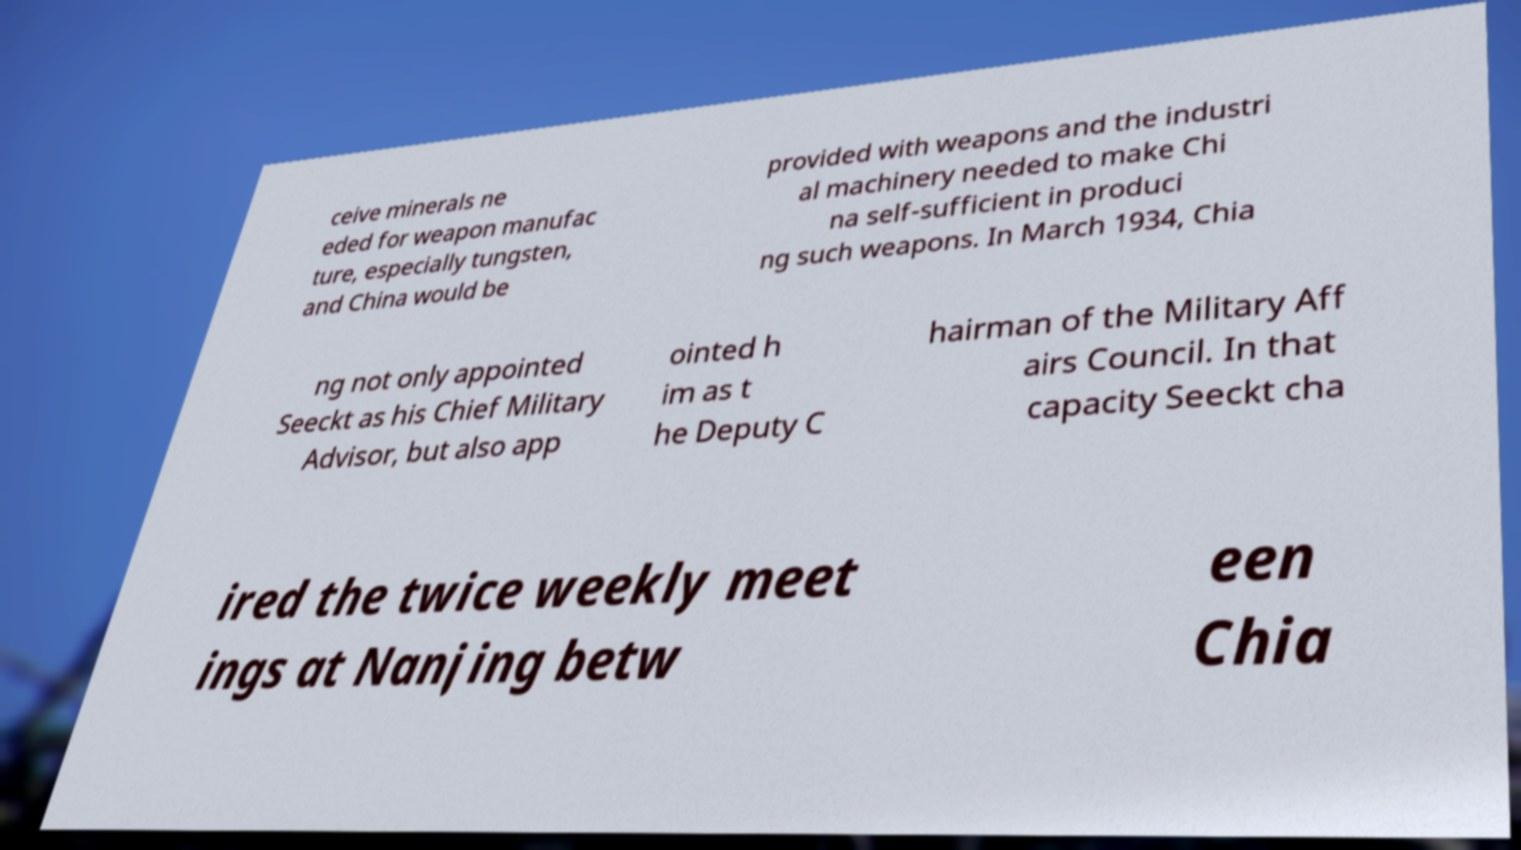There's text embedded in this image that I need extracted. Can you transcribe it verbatim? ceive minerals ne eded for weapon manufac ture, especially tungsten, and China would be provided with weapons and the industri al machinery needed to make Chi na self-sufficient in produci ng such weapons. In March 1934, Chia ng not only appointed Seeckt as his Chief Military Advisor, but also app ointed h im as t he Deputy C hairman of the Military Aff airs Council. In that capacity Seeckt cha ired the twice weekly meet ings at Nanjing betw een Chia 